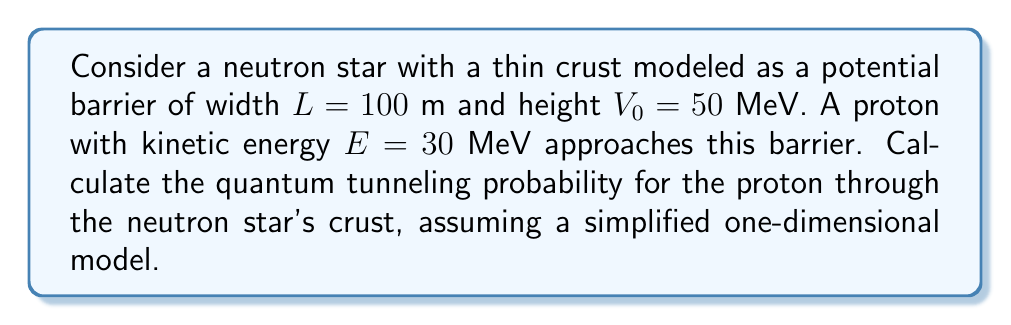Show me your answer to this math problem. To solve this problem, we'll use the quantum tunneling formula for a rectangular potential barrier:

1) The tunneling probability $T$ is given by:

   $$T \approx e^{-2\kappa L}$$

   where $\kappa$ is the decay constant inside the barrier.

2) The decay constant $\kappa$ is defined as:

   $$\kappa = \frac{\sqrt{2m(V_0 - E)}}{\hbar}$$

   where $m$ is the mass of the particle, $V_0$ is the barrier height, and $E$ is the particle's energy.

3) Let's substitute the known values:
   - $m = 1.67 \times 10^{-27}$ kg (proton mass)
   - $V_0 = 50$ MeV $= 8.01 \times 10^{-12}$ J
   - $E = 30$ MeV $= 4.81 \times 10^{-12}$ J
   - $L = 100$ m
   - $\hbar = 1.05 \times 10^{-34}$ J·s

4) Calculate $\kappa$:

   $$\kappa = \frac{\sqrt{2(1.67 \times 10^{-27})(8.01 \times 10^{-12} - 4.81 \times 10^{-12})}}{1.05 \times 10^{-34}} = 3.76 \times 10^{13} \text{ m}^{-1}$$

5) Now we can calculate the tunneling probability:

   $$T \approx e^{-2(3.76 \times 10^{13})(100)} = e^{-7.52 \times 10^{15}} \approx 0$$

The tunneling probability is effectively zero, demonstrating the extreme improbability of a proton tunneling through a neutron star's crust in this simplified model.
Answer: $T \approx 0$ 